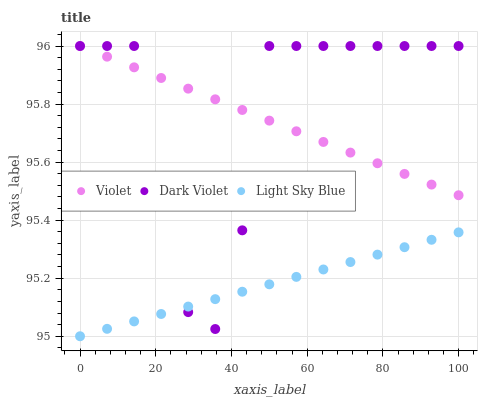Does Light Sky Blue have the minimum area under the curve?
Answer yes or no. Yes. Does Dark Violet have the maximum area under the curve?
Answer yes or no. Yes. Does Violet have the minimum area under the curve?
Answer yes or no. No. Does Violet have the maximum area under the curve?
Answer yes or no. No. Is Violet the smoothest?
Answer yes or no. Yes. Is Dark Violet the roughest?
Answer yes or no. Yes. Is Dark Violet the smoothest?
Answer yes or no. No. Is Violet the roughest?
Answer yes or no. No. Does Light Sky Blue have the lowest value?
Answer yes or no. Yes. Does Dark Violet have the lowest value?
Answer yes or no. No. Does Violet have the highest value?
Answer yes or no. Yes. Is Light Sky Blue less than Violet?
Answer yes or no. Yes. Is Violet greater than Light Sky Blue?
Answer yes or no. Yes. Does Violet intersect Dark Violet?
Answer yes or no. Yes. Is Violet less than Dark Violet?
Answer yes or no. No. Is Violet greater than Dark Violet?
Answer yes or no. No. Does Light Sky Blue intersect Violet?
Answer yes or no. No. 